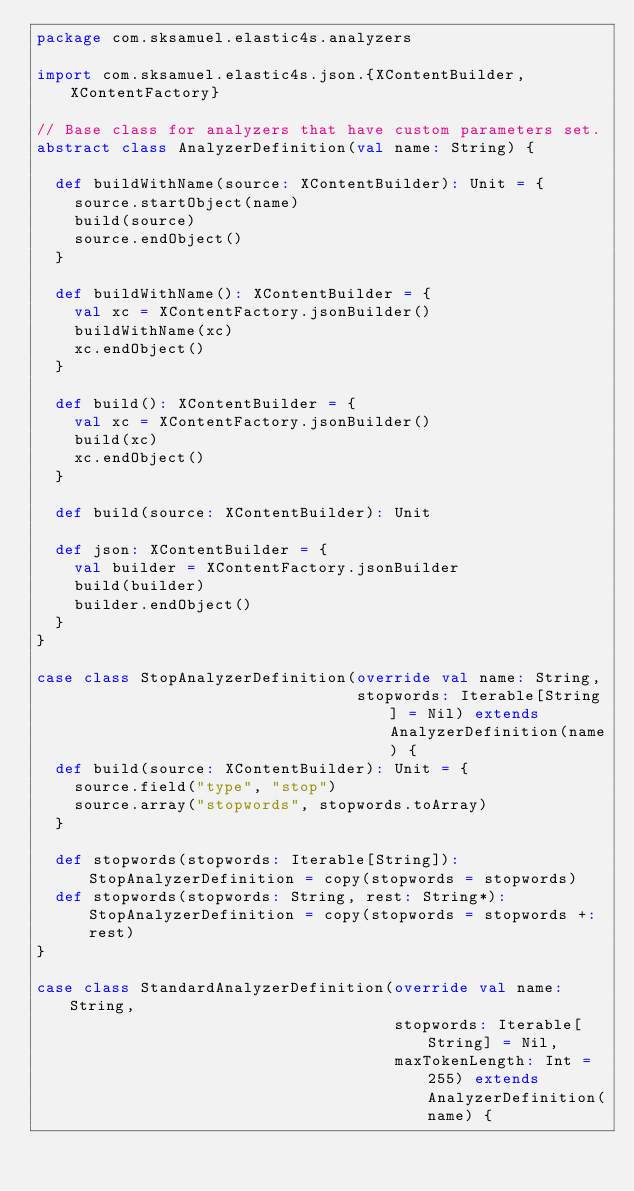<code> <loc_0><loc_0><loc_500><loc_500><_Scala_>package com.sksamuel.elastic4s.analyzers

import com.sksamuel.elastic4s.json.{XContentBuilder, XContentFactory}

// Base class for analyzers that have custom parameters set.
abstract class AnalyzerDefinition(val name: String) {

  def buildWithName(source: XContentBuilder): Unit = {
    source.startObject(name)
    build(source)
    source.endObject()
  }

  def buildWithName(): XContentBuilder = {
    val xc = XContentFactory.jsonBuilder()
    buildWithName(xc)
    xc.endObject()
  }

  def build(): XContentBuilder = {
    val xc = XContentFactory.jsonBuilder()
    build(xc)
    xc.endObject()
  }

  def build(source: XContentBuilder): Unit

  def json: XContentBuilder = {
    val builder = XContentFactory.jsonBuilder
    build(builder)
    builder.endObject()
  }
}

case class StopAnalyzerDefinition(override val name: String,
                                  stopwords: Iterable[String] = Nil) extends AnalyzerDefinition(name) {
  def build(source: XContentBuilder): Unit = {
    source.field("type", "stop")
    source.array("stopwords", stopwords.toArray)
  }

  def stopwords(stopwords: Iterable[String]): StopAnalyzerDefinition = copy(stopwords = stopwords)
  def stopwords(stopwords: String, rest: String*): StopAnalyzerDefinition = copy(stopwords = stopwords +: rest)
}

case class StandardAnalyzerDefinition(override val name: String,
                                      stopwords: Iterable[String] = Nil,
                                      maxTokenLength: Int = 255) extends AnalyzerDefinition(name) {</code> 